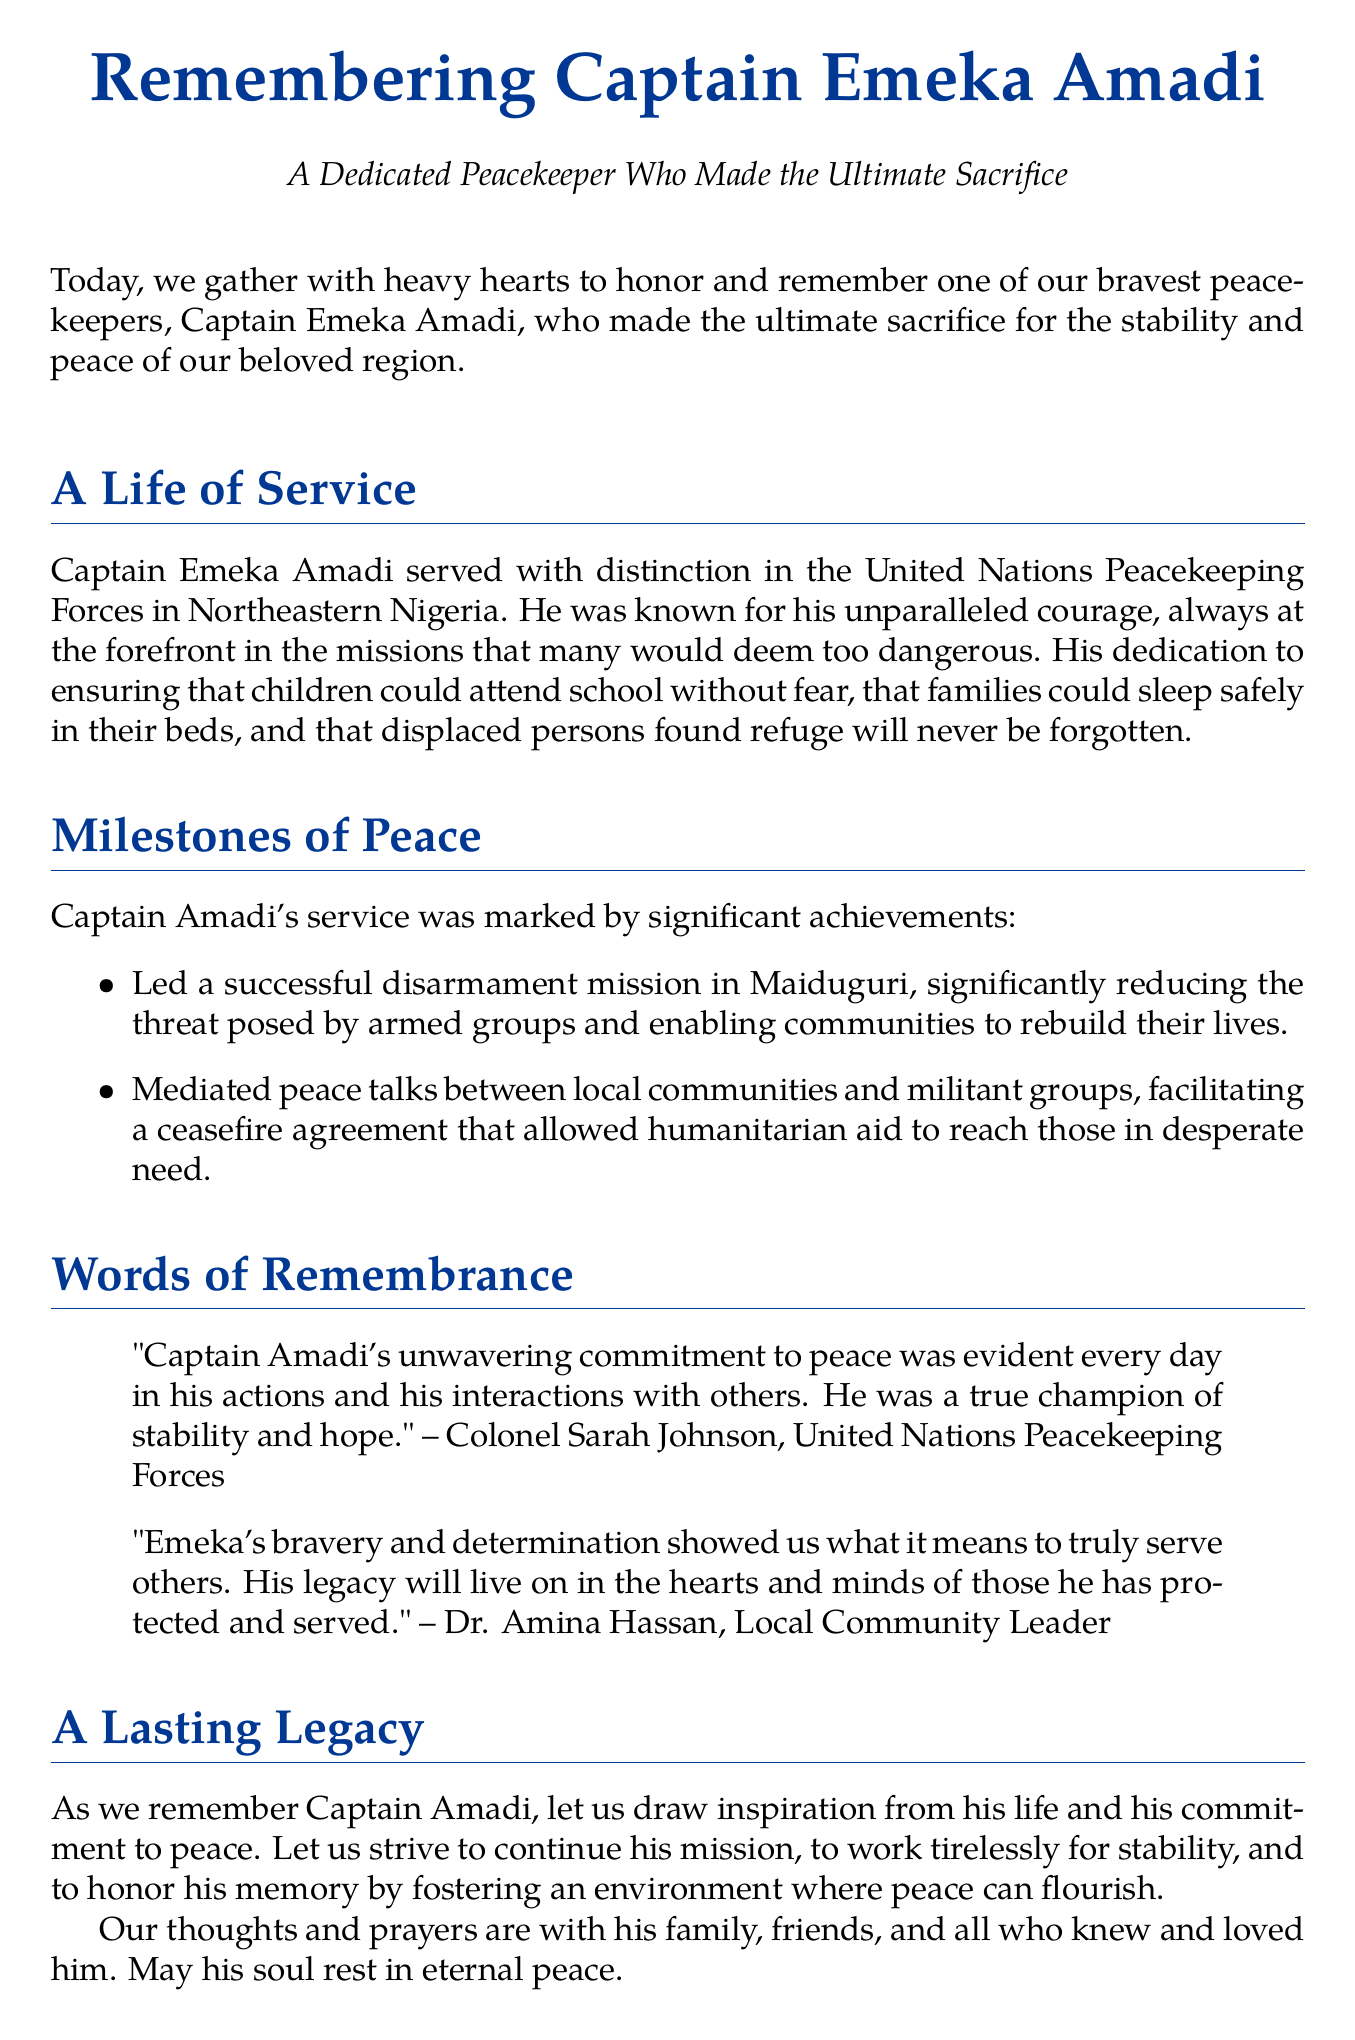What is the name of the peacekeeper honored in the document? The document specifically names Captain Emeka Amadi as the honored peacekeeper.
Answer: Captain Emeka Amadi In which region did Captain Emeka Amadi serve? The document states that Captain Emeka Amadi served in Northeastern Nigeria.
Answer: Northeastern Nigeria What did Captain Emeka Amadi lead that significantly reduced the threat of armed groups? The document mentions that he led a successful disarmament mission in Maiduguri.
Answer: disarmament mission Who is quoted in the document stating Captain Amadi was a champion of stability? Colonel Sarah Johnson is quoted in the document regarding Captain Amadi's commitment to peace.
Answer: Colonel Sarah Johnson What was the outcome of the peace talks mediated by Captain Emeka Amadi? The document notes that the peace talks facilitated a ceasefire agreement.
Answer: ceasefire agreement Which organization did Captain Emeka Amadi serve with? The document states he served with the United Nations Peacekeeping Forces.
Answer: United Nations Peacekeeping Forces What is a significant characteristic of Captain Amadi as noted in the eulogy? The eulogy highlights his unparalleled courage throughout his missions.
Answer: unparalleled courage What sentiment is expressed towards Captain Amadi's legacy? The document expresses that his legacy will live on in the hearts and minds of those he protected.
Answer: live on in the hearts and minds What is the closing sentiment of the document regarding Captain Emeka Amadi? The document concludes with prayers for his family and a wish for his soul to rest in eternal peace.
Answer: rest in eternal peace 